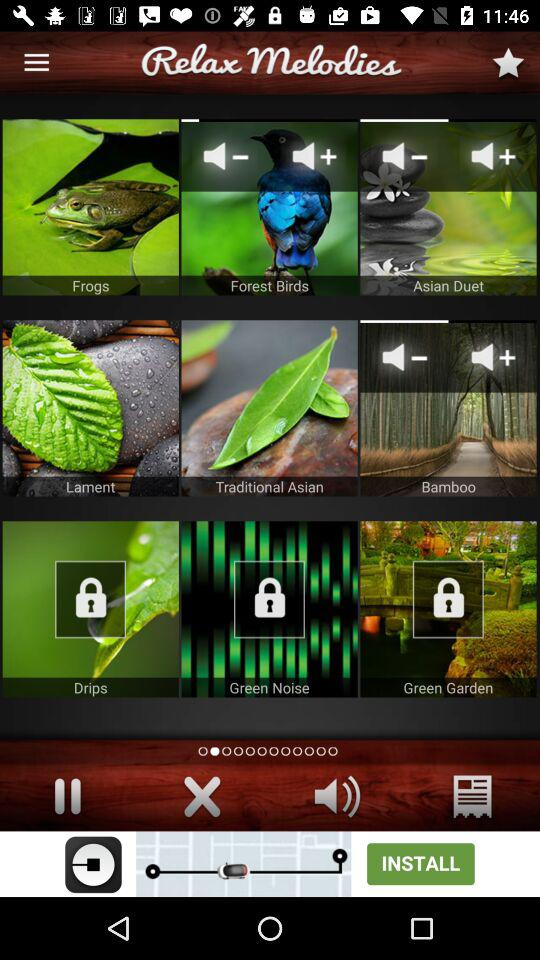Which melodies are locked? The locked melodies are "Drips", "Green Noise" and "Green Garden". 